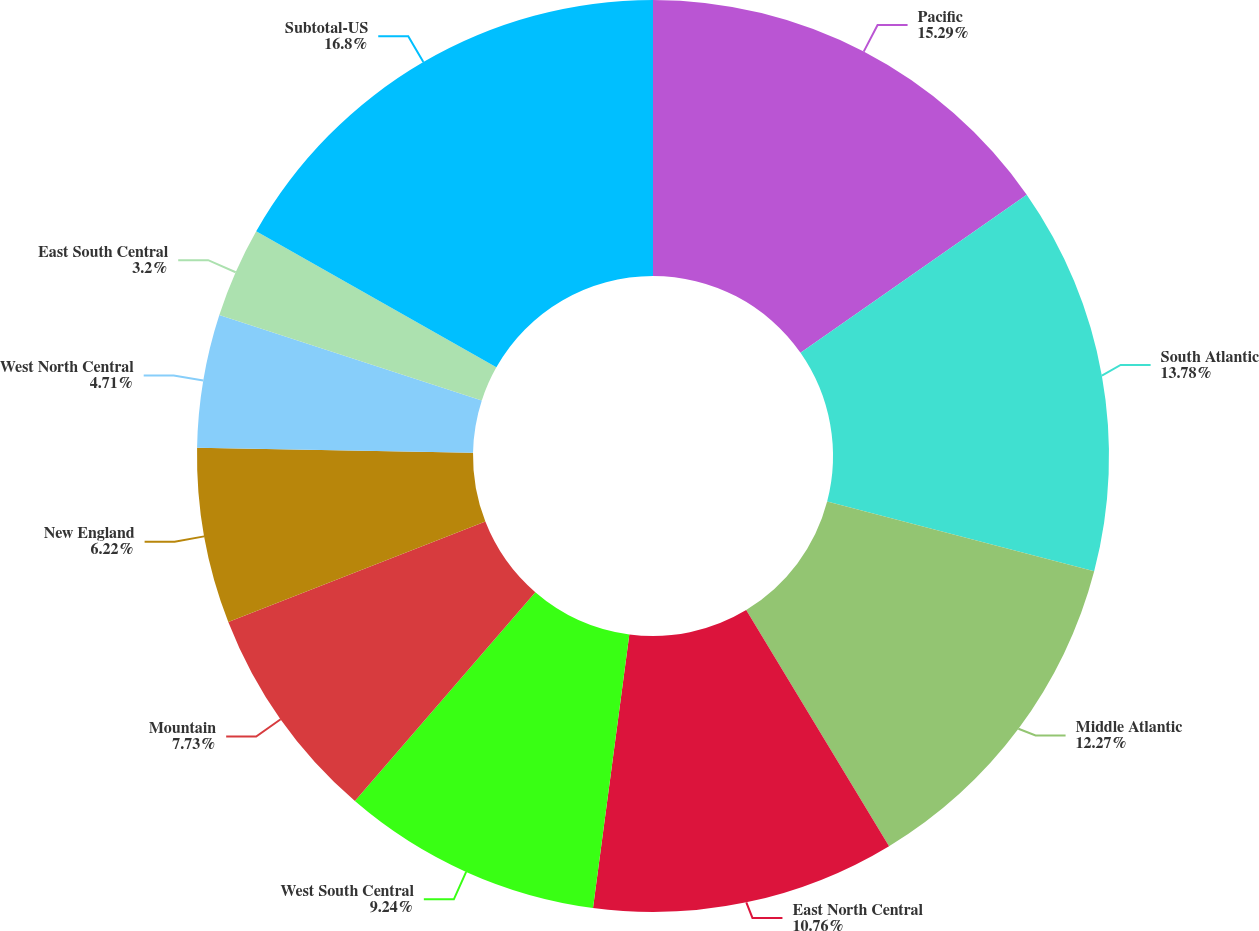Convert chart to OTSL. <chart><loc_0><loc_0><loc_500><loc_500><pie_chart><fcel>Pacific<fcel>South Atlantic<fcel>Middle Atlantic<fcel>East North Central<fcel>West South Central<fcel>Mountain<fcel>New England<fcel>West North Central<fcel>East South Central<fcel>Subtotal-US<nl><fcel>15.29%<fcel>13.78%<fcel>12.27%<fcel>10.76%<fcel>9.24%<fcel>7.73%<fcel>6.22%<fcel>4.71%<fcel>3.2%<fcel>16.8%<nl></chart> 